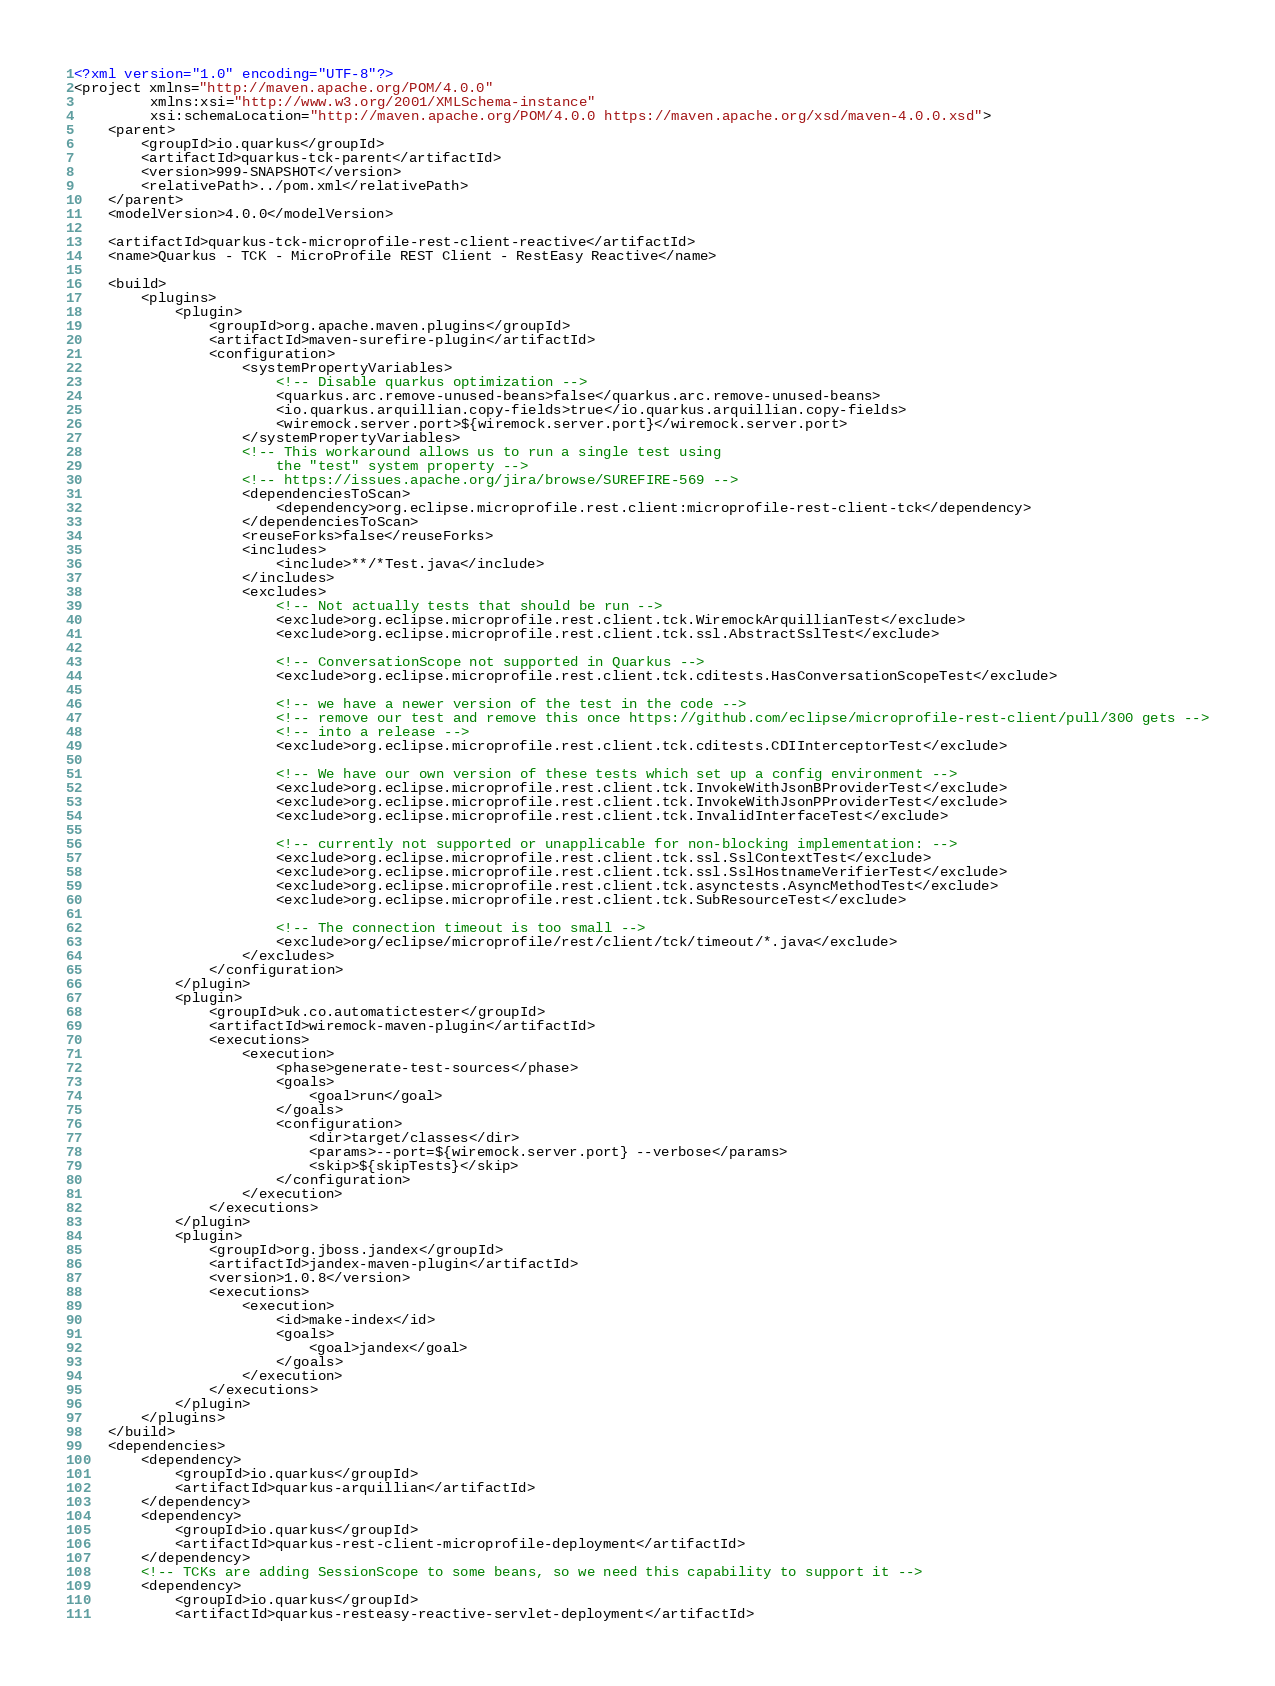Convert code to text. <code><loc_0><loc_0><loc_500><loc_500><_XML_><?xml version="1.0" encoding="UTF-8"?>
<project xmlns="http://maven.apache.org/POM/4.0.0"
         xmlns:xsi="http://www.w3.org/2001/XMLSchema-instance"
         xsi:schemaLocation="http://maven.apache.org/POM/4.0.0 https://maven.apache.org/xsd/maven-4.0.0.xsd">
    <parent>
        <groupId>io.quarkus</groupId>
        <artifactId>quarkus-tck-parent</artifactId>
        <version>999-SNAPSHOT</version>
        <relativePath>../pom.xml</relativePath>
    </parent>
    <modelVersion>4.0.0</modelVersion>

    <artifactId>quarkus-tck-microprofile-rest-client-reactive</artifactId>
    <name>Quarkus - TCK - MicroProfile REST Client - RestEasy Reactive</name>

    <build>
        <plugins>
            <plugin>
                <groupId>org.apache.maven.plugins</groupId>
                <artifactId>maven-surefire-plugin</artifactId>
                <configuration>
                    <systemPropertyVariables>
                        <!-- Disable quarkus optimization -->
                        <quarkus.arc.remove-unused-beans>false</quarkus.arc.remove-unused-beans>
                        <io.quarkus.arquillian.copy-fields>true</io.quarkus.arquillian.copy-fields>
                        <wiremock.server.port>${wiremock.server.port}</wiremock.server.port>
                    </systemPropertyVariables>
                    <!-- This workaround allows us to run a single test using
                        the "test" system property -->
                    <!-- https://issues.apache.org/jira/browse/SUREFIRE-569 -->
                    <dependenciesToScan>
                        <dependency>org.eclipse.microprofile.rest.client:microprofile-rest-client-tck</dependency>
                    </dependenciesToScan>
                    <reuseForks>false</reuseForks>
                    <includes>
                        <include>**/*Test.java</include>
                    </includes>
                    <excludes>
                        <!-- Not actually tests that should be run -->
                        <exclude>org.eclipse.microprofile.rest.client.tck.WiremockArquillianTest</exclude>
                        <exclude>org.eclipse.microprofile.rest.client.tck.ssl.AbstractSslTest</exclude>

                        <!-- ConversationScope not supported in Quarkus -->
                        <exclude>org.eclipse.microprofile.rest.client.tck.cditests.HasConversationScopeTest</exclude>

                        <!-- we have a newer version of the test in the code -->
                        <!-- remove our test and remove this once https://github.com/eclipse/microprofile-rest-client/pull/300 gets -->
                        <!-- into a release -->
                        <exclude>org.eclipse.microprofile.rest.client.tck.cditests.CDIInterceptorTest</exclude>

                        <!-- We have our own version of these tests which set up a config environment -->
                        <exclude>org.eclipse.microprofile.rest.client.tck.InvokeWithJsonBProviderTest</exclude>
                        <exclude>org.eclipse.microprofile.rest.client.tck.InvokeWithJsonPProviderTest</exclude>
                        <exclude>org.eclipse.microprofile.rest.client.tck.InvalidInterfaceTest</exclude>

                        <!-- currently not supported or unapplicable for non-blocking implementation: -->
                        <exclude>org.eclipse.microprofile.rest.client.tck.ssl.SslContextTest</exclude>
                        <exclude>org.eclipse.microprofile.rest.client.tck.ssl.SslHostnameVerifierTest</exclude>
                        <exclude>org.eclipse.microprofile.rest.client.tck.asynctests.AsyncMethodTest</exclude>
                        <exclude>org.eclipse.microprofile.rest.client.tck.SubResourceTest</exclude>

                        <!-- The connection timeout is too small -->
                        <exclude>org/eclipse/microprofile/rest/client/tck/timeout/*.java</exclude>
                    </excludes>
                </configuration>
            </plugin>
            <plugin>
                <groupId>uk.co.automatictester</groupId>
                <artifactId>wiremock-maven-plugin</artifactId>
                <executions>
                    <execution>
                        <phase>generate-test-sources</phase>
                        <goals>
                            <goal>run</goal>
                        </goals>
                        <configuration>
                            <dir>target/classes</dir>
                            <params>--port=${wiremock.server.port} --verbose</params>
                            <skip>${skipTests}</skip>
                        </configuration>
                    </execution>
                </executions>
            </plugin>
            <plugin>
                <groupId>org.jboss.jandex</groupId>
                <artifactId>jandex-maven-plugin</artifactId>
                <version>1.0.8</version>
                <executions>
                    <execution>
                        <id>make-index</id>
                        <goals>
                            <goal>jandex</goal>
                        </goals>
                    </execution>
                </executions>
            </plugin>
        </plugins>
    </build>
    <dependencies>
        <dependency>
            <groupId>io.quarkus</groupId>
            <artifactId>quarkus-arquillian</artifactId>
        </dependency>
        <dependency>
            <groupId>io.quarkus</groupId>
            <artifactId>quarkus-rest-client-microprofile-deployment</artifactId>
        </dependency>
        <!-- TCKs are adding SessionScope to some beans, so we need this capability to support it -->
        <dependency>
            <groupId>io.quarkus</groupId>
            <artifactId>quarkus-resteasy-reactive-servlet-deployment</artifactId></code> 